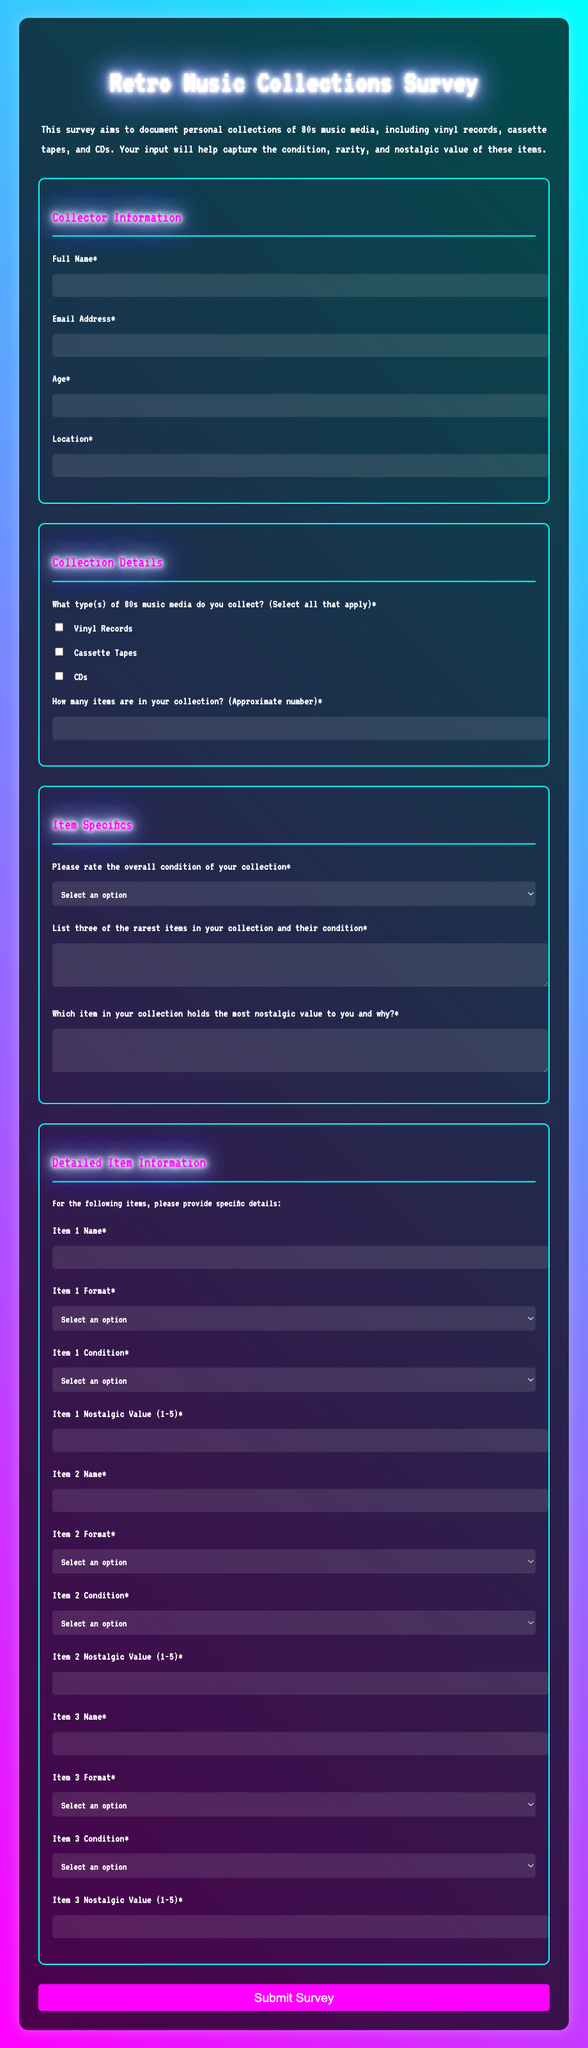What is the main purpose of the survey? The purpose of the survey is to document personal collections of 80s music media, including various formats.
Answer: Documenting 80s music collections What formats of media can be selected in the collection details? The format options available include Vinyl Records, Cassette Tapes, and CDs.
Answer: Vinyl Records, Cassette Tapes, CDs How many items does the form ask for in the collection size question? The form requests the approximate number of items in the collection.
Answer: Number of items What rating options are provided for the overall condition of the collection? The rating options include Mint/New, Excellent, Good, Fair, and Poor.
Answer: Mint/New, Excellent, Good, Fair, Poor How many rare items must be listed in the specific details section? The form asks for three of the rarest items to be listed along with their condition.
Answer: Three items What is the maximum nostalgic value rating one can assign to an item? The nostalgic value for each item can be rated on a scale from 1 to 5.
Answer: 5 What is the required completion status of the fields for the survey? All fields marked with an asterisk (*) are required to be filled out before submission.
Answer: Required fields What is the main theme of the color scheme used in the document? The main colors used in the document are magenta and cyan, creating a retro aesthetic.
Answer: Magenta and cyan 